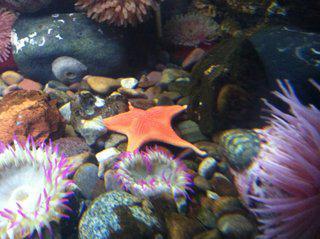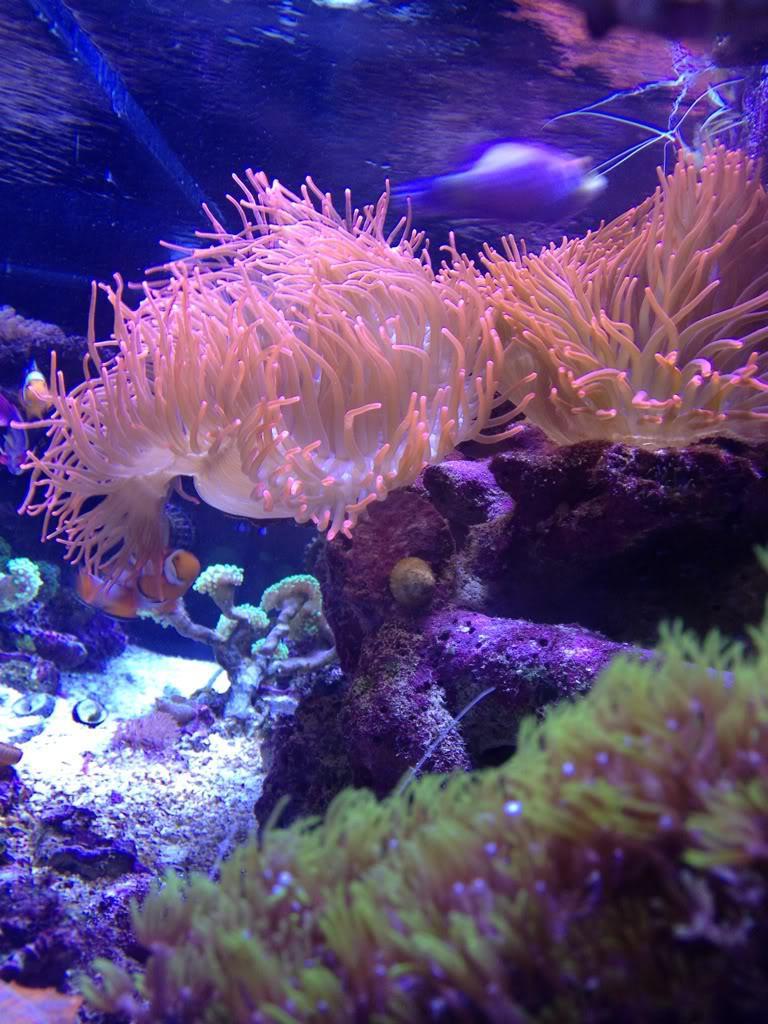The first image is the image on the left, the second image is the image on the right. For the images displayed, is the sentence "There are orange, black and white stripe section on a single cloud fish that is in the arms of the corral." factually correct? Answer yes or no. No. The first image is the image on the left, the second image is the image on the right. Analyze the images presented: Is the assertion "The left image shows one starfish swimming above anemone tendrils, and the right image includes a red-orange anemone." valid? Answer yes or no. No. 